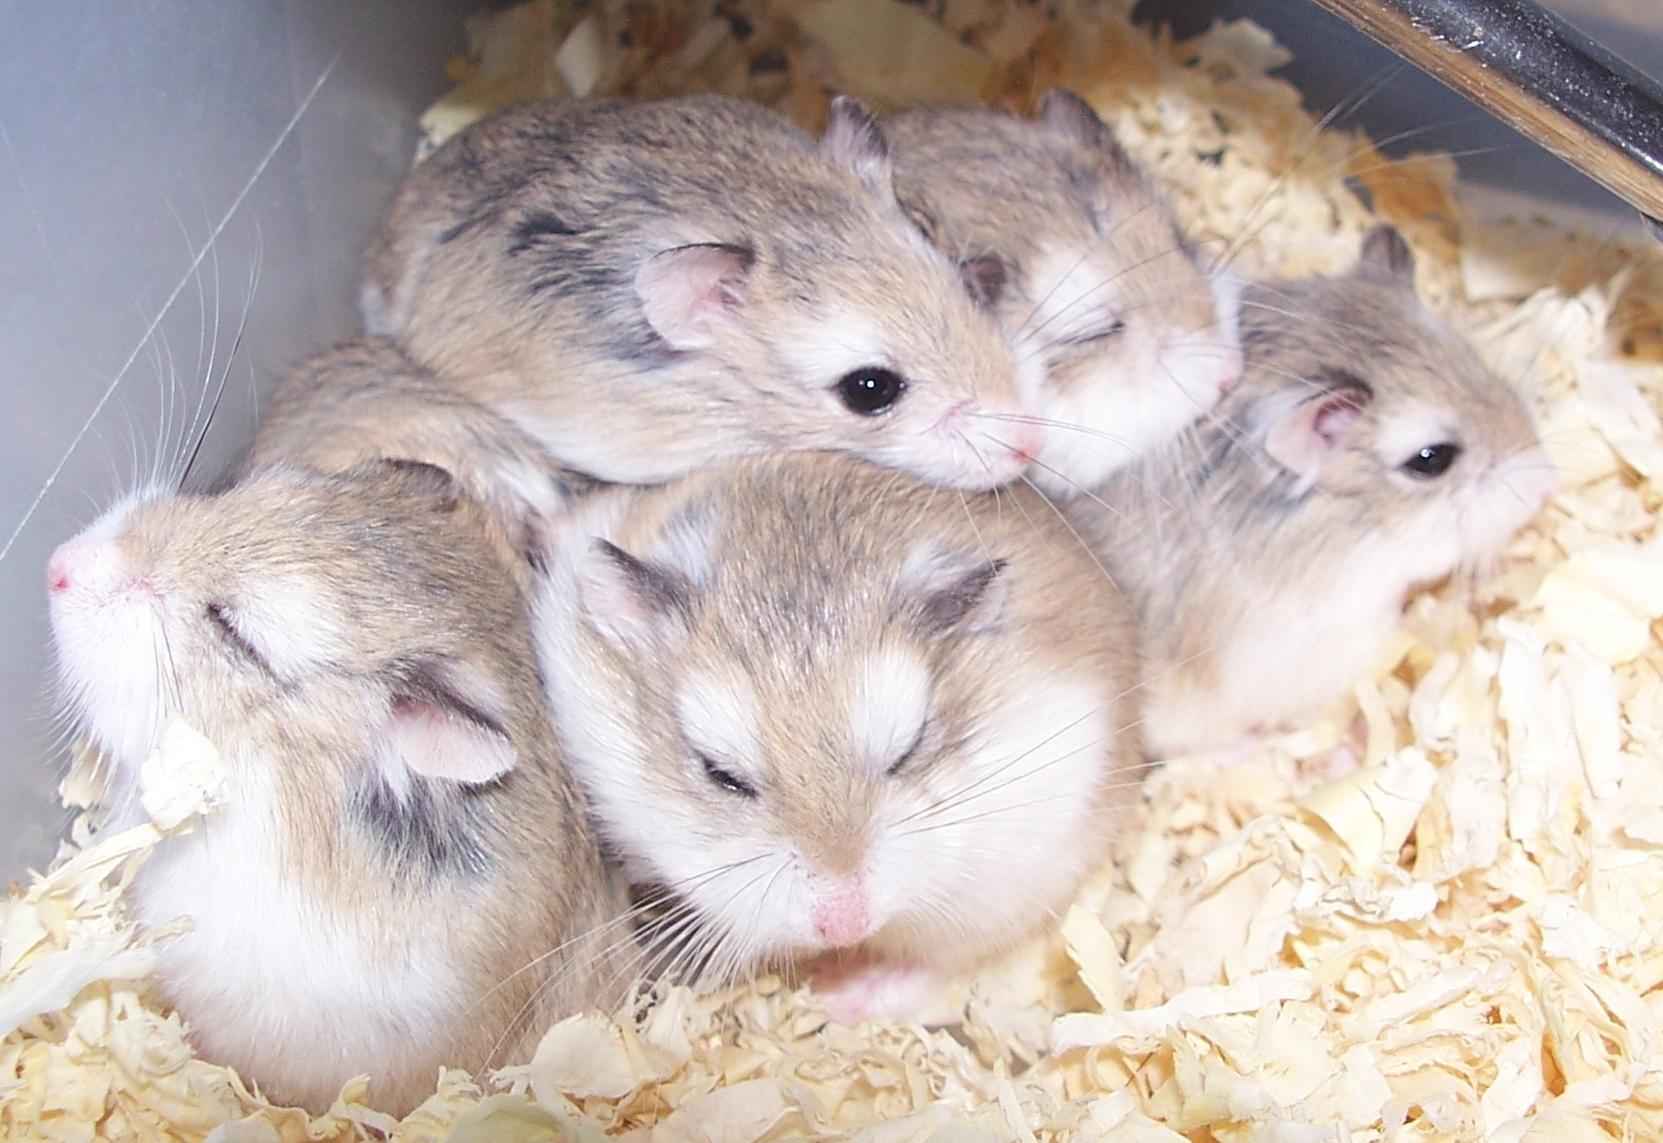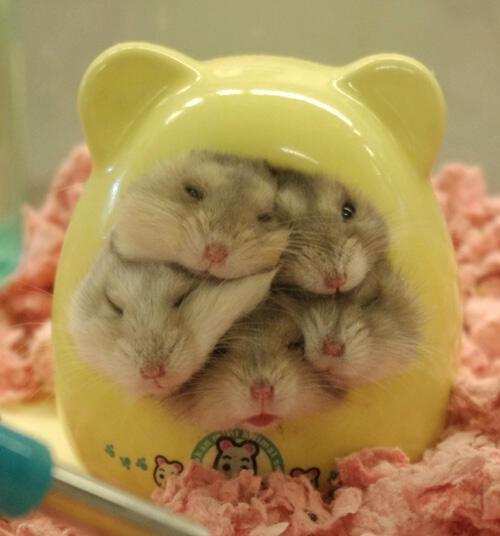The first image is the image on the left, the second image is the image on the right. Evaluate the accuracy of this statement regarding the images: "One of the images shows hamsters crowded inside a container that has ears on top of it.". Is it true? Answer yes or no. Yes. 